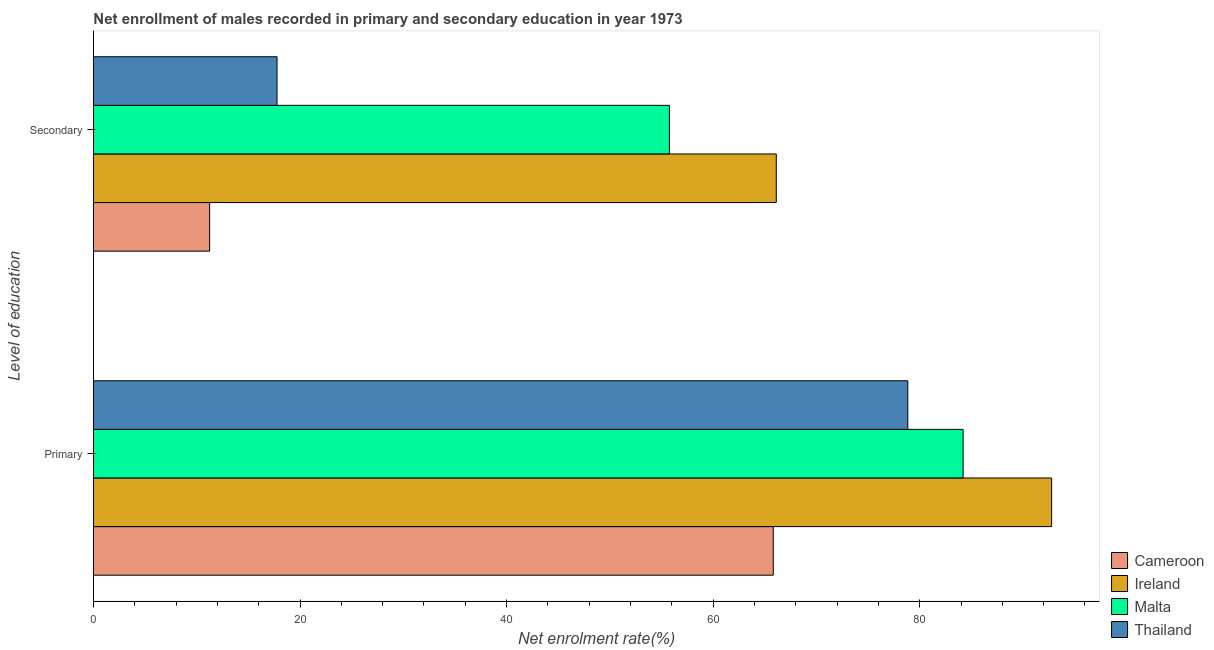Are the number of bars per tick equal to the number of legend labels?
Offer a very short reply. Yes. What is the label of the 1st group of bars from the top?
Your answer should be compact. Secondary. What is the enrollment rate in secondary education in Cameroon?
Your answer should be compact. 11.25. Across all countries, what is the maximum enrollment rate in primary education?
Your answer should be very brief. 92.77. Across all countries, what is the minimum enrollment rate in primary education?
Keep it short and to the point. 65.82. In which country was the enrollment rate in primary education maximum?
Provide a succinct answer. Ireland. In which country was the enrollment rate in primary education minimum?
Make the answer very short. Cameroon. What is the total enrollment rate in primary education in the graph?
Offer a very short reply. 321.64. What is the difference between the enrollment rate in primary education in Ireland and that in Cameroon?
Your answer should be compact. 26.95. What is the difference between the enrollment rate in secondary education in Thailand and the enrollment rate in primary education in Cameroon?
Your answer should be very brief. -48.05. What is the average enrollment rate in primary education per country?
Ensure brevity in your answer.  80.41. What is the difference between the enrollment rate in secondary education and enrollment rate in primary education in Ireland?
Provide a short and direct response. -26.66. What is the ratio of the enrollment rate in primary education in Malta to that in Thailand?
Your response must be concise. 1.07. Is the enrollment rate in secondary education in Malta less than that in Ireland?
Provide a succinct answer. Yes. What does the 2nd bar from the top in Secondary represents?
Keep it short and to the point. Malta. What does the 3rd bar from the bottom in Secondary represents?
Provide a short and direct response. Malta. Does the graph contain grids?
Offer a very short reply. No. Where does the legend appear in the graph?
Your answer should be compact. Bottom right. What is the title of the graph?
Your answer should be compact. Net enrollment of males recorded in primary and secondary education in year 1973. Does "Guinea-Bissau" appear as one of the legend labels in the graph?
Offer a very short reply. No. What is the label or title of the X-axis?
Your response must be concise. Net enrolment rate(%). What is the label or title of the Y-axis?
Your answer should be very brief. Level of education. What is the Net enrolment rate(%) in Cameroon in Primary?
Offer a very short reply. 65.82. What is the Net enrolment rate(%) of Ireland in Primary?
Your answer should be very brief. 92.77. What is the Net enrolment rate(%) in Malta in Primary?
Keep it short and to the point. 84.2. What is the Net enrolment rate(%) in Thailand in Primary?
Make the answer very short. 78.85. What is the Net enrolment rate(%) of Cameroon in Secondary?
Offer a terse response. 11.25. What is the Net enrolment rate(%) in Ireland in Secondary?
Ensure brevity in your answer.  66.11. What is the Net enrolment rate(%) of Malta in Secondary?
Make the answer very short. 55.76. What is the Net enrolment rate(%) in Thailand in Secondary?
Make the answer very short. 17.77. Across all Level of education, what is the maximum Net enrolment rate(%) in Cameroon?
Provide a succinct answer. 65.82. Across all Level of education, what is the maximum Net enrolment rate(%) of Ireland?
Make the answer very short. 92.77. Across all Level of education, what is the maximum Net enrolment rate(%) in Malta?
Offer a terse response. 84.2. Across all Level of education, what is the maximum Net enrolment rate(%) of Thailand?
Your answer should be very brief. 78.85. Across all Level of education, what is the minimum Net enrolment rate(%) in Cameroon?
Provide a short and direct response. 11.25. Across all Level of education, what is the minimum Net enrolment rate(%) of Ireland?
Offer a terse response. 66.11. Across all Level of education, what is the minimum Net enrolment rate(%) of Malta?
Ensure brevity in your answer.  55.76. Across all Level of education, what is the minimum Net enrolment rate(%) in Thailand?
Make the answer very short. 17.77. What is the total Net enrolment rate(%) of Cameroon in the graph?
Your response must be concise. 77.07. What is the total Net enrolment rate(%) of Ireland in the graph?
Make the answer very short. 158.88. What is the total Net enrolment rate(%) of Malta in the graph?
Your answer should be very brief. 139.96. What is the total Net enrolment rate(%) of Thailand in the graph?
Your answer should be very brief. 96.62. What is the difference between the Net enrolment rate(%) in Cameroon in Primary and that in Secondary?
Keep it short and to the point. 54.57. What is the difference between the Net enrolment rate(%) in Ireland in Primary and that in Secondary?
Provide a short and direct response. 26.66. What is the difference between the Net enrolment rate(%) of Malta in Primary and that in Secondary?
Provide a short and direct response. 28.44. What is the difference between the Net enrolment rate(%) of Thailand in Primary and that in Secondary?
Give a very brief answer. 61.07. What is the difference between the Net enrolment rate(%) of Cameroon in Primary and the Net enrolment rate(%) of Ireland in Secondary?
Offer a terse response. -0.29. What is the difference between the Net enrolment rate(%) of Cameroon in Primary and the Net enrolment rate(%) of Malta in Secondary?
Your answer should be very brief. 10.06. What is the difference between the Net enrolment rate(%) of Cameroon in Primary and the Net enrolment rate(%) of Thailand in Secondary?
Offer a terse response. 48.05. What is the difference between the Net enrolment rate(%) of Ireland in Primary and the Net enrolment rate(%) of Malta in Secondary?
Keep it short and to the point. 37.01. What is the difference between the Net enrolment rate(%) in Ireland in Primary and the Net enrolment rate(%) in Thailand in Secondary?
Make the answer very short. 75. What is the difference between the Net enrolment rate(%) in Malta in Primary and the Net enrolment rate(%) in Thailand in Secondary?
Provide a short and direct response. 66.43. What is the average Net enrolment rate(%) in Cameroon per Level of education?
Your answer should be very brief. 38.53. What is the average Net enrolment rate(%) of Ireland per Level of education?
Provide a short and direct response. 79.44. What is the average Net enrolment rate(%) in Malta per Level of education?
Make the answer very short. 69.98. What is the average Net enrolment rate(%) in Thailand per Level of education?
Make the answer very short. 48.31. What is the difference between the Net enrolment rate(%) in Cameroon and Net enrolment rate(%) in Ireland in Primary?
Your answer should be compact. -26.95. What is the difference between the Net enrolment rate(%) in Cameroon and Net enrolment rate(%) in Malta in Primary?
Your response must be concise. -18.38. What is the difference between the Net enrolment rate(%) in Cameroon and Net enrolment rate(%) in Thailand in Primary?
Ensure brevity in your answer.  -13.03. What is the difference between the Net enrolment rate(%) of Ireland and Net enrolment rate(%) of Malta in Primary?
Make the answer very short. 8.57. What is the difference between the Net enrolment rate(%) in Ireland and Net enrolment rate(%) in Thailand in Primary?
Your answer should be very brief. 13.93. What is the difference between the Net enrolment rate(%) in Malta and Net enrolment rate(%) in Thailand in Primary?
Your answer should be very brief. 5.36. What is the difference between the Net enrolment rate(%) in Cameroon and Net enrolment rate(%) in Ireland in Secondary?
Give a very brief answer. -54.86. What is the difference between the Net enrolment rate(%) in Cameroon and Net enrolment rate(%) in Malta in Secondary?
Provide a short and direct response. -44.52. What is the difference between the Net enrolment rate(%) in Cameroon and Net enrolment rate(%) in Thailand in Secondary?
Give a very brief answer. -6.53. What is the difference between the Net enrolment rate(%) of Ireland and Net enrolment rate(%) of Malta in Secondary?
Offer a very short reply. 10.35. What is the difference between the Net enrolment rate(%) of Ireland and Net enrolment rate(%) of Thailand in Secondary?
Your answer should be very brief. 48.34. What is the difference between the Net enrolment rate(%) of Malta and Net enrolment rate(%) of Thailand in Secondary?
Offer a very short reply. 37.99. What is the ratio of the Net enrolment rate(%) of Cameroon in Primary to that in Secondary?
Your response must be concise. 5.85. What is the ratio of the Net enrolment rate(%) in Ireland in Primary to that in Secondary?
Make the answer very short. 1.4. What is the ratio of the Net enrolment rate(%) in Malta in Primary to that in Secondary?
Provide a succinct answer. 1.51. What is the ratio of the Net enrolment rate(%) in Thailand in Primary to that in Secondary?
Your response must be concise. 4.44. What is the difference between the highest and the second highest Net enrolment rate(%) in Cameroon?
Provide a short and direct response. 54.57. What is the difference between the highest and the second highest Net enrolment rate(%) in Ireland?
Make the answer very short. 26.66. What is the difference between the highest and the second highest Net enrolment rate(%) of Malta?
Provide a succinct answer. 28.44. What is the difference between the highest and the second highest Net enrolment rate(%) of Thailand?
Keep it short and to the point. 61.07. What is the difference between the highest and the lowest Net enrolment rate(%) in Cameroon?
Provide a succinct answer. 54.57. What is the difference between the highest and the lowest Net enrolment rate(%) in Ireland?
Offer a very short reply. 26.66. What is the difference between the highest and the lowest Net enrolment rate(%) of Malta?
Provide a succinct answer. 28.44. What is the difference between the highest and the lowest Net enrolment rate(%) of Thailand?
Give a very brief answer. 61.07. 